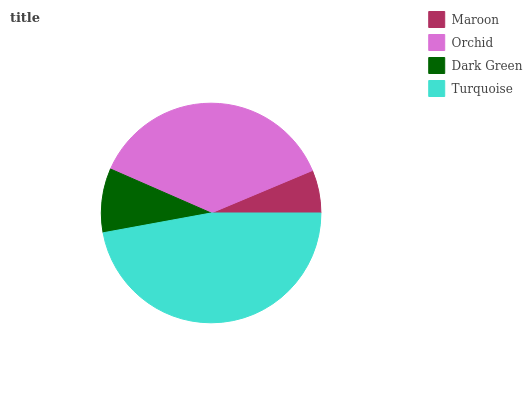Is Maroon the minimum?
Answer yes or no. Yes. Is Turquoise the maximum?
Answer yes or no. Yes. Is Orchid the minimum?
Answer yes or no. No. Is Orchid the maximum?
Answer yes or no. No. Is Orchid greater than Maroon?
Answer yes or no. Yes. Is Maroon less than Orchid?
Answer yes or no. Yes. Is Maroon greater than Orchid?
Answer yes or no. No. Is Orchid less than Maroon?
Answer yes or no. No. Is Orchid the high median?
Answer yes or no. Yes. Is Dark Green the low median?
Answer yes or no. Yes. Is Dark Green the high median?
Answer yes or no. No. Is Maroon the low median?
Answer yes or no. No. 